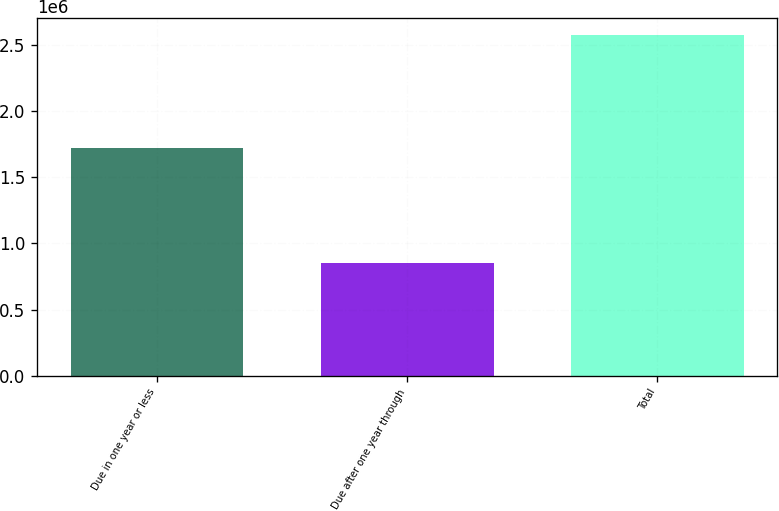<chart> <loc_0><loc_0><loc_500><loc_500><bar_chart><fcel>Due in one year or less<fcel>Due after one year through<fcel>Total<nl><fcel>1.72255e+06<fcel>851547<fcel>2.5741e+06<nl></chart> 